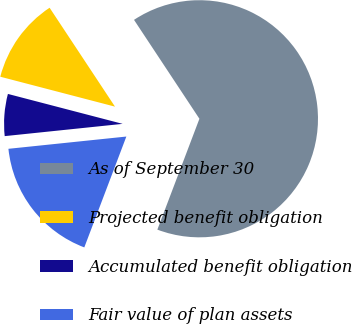Convert chart. <chart><loc_0><loc_0><loc_500><loc_500><pie_chart><fcel>As of September 30<fcel>Projected benefit obligation<fcel>Accumulated benefit obligation<fcel>Fair value of plan assets<nl><fcel>65.07%<fcel>11.64%<fcel>5.71%<fcel>17.58%<nl></chart> 